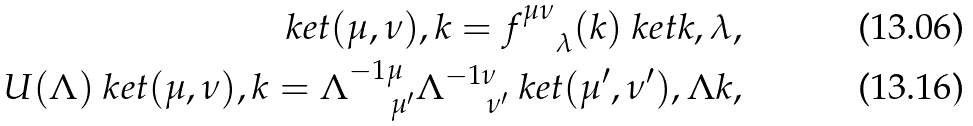<formula> <loc_0><loc_0><loc_500><loc_500>\ k e t { ( \mu , \nu ) , k } = f ^ { \mu \nu } _ { \quad \lambda } ( k ) \ k e t { k , \lambda } , \\ U ( \Lambda ) \ k e t { ( \mu , \nu ) , k } = \Lambda ^ { - 1 \mu } _ { \, \quad \mu ^ { \prime } } \Lambda ^ { - 1 \nu } _ { \, \quad \nu ^ { \prime } } \ k e t { ( \mu ^ { \prime } , \nu ^ { \prime } ) , \Lambda k } ,</formula> 